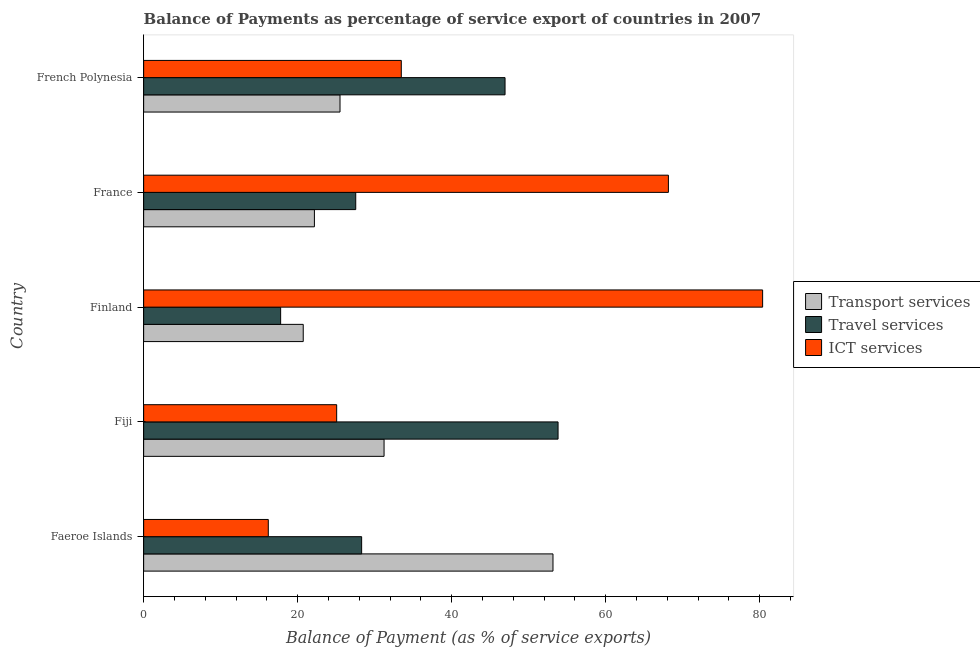How many groups of bars are there?
Offer a terse response. 5. Are the number of bars on each tick of the Y-axis equal?
Offer a terse response. Yes. How many bars are there on the 5th tick from the bottom?
Make the answer very short. 3. What is the label of the 2nd group of bars from the top?
Your answer should be very brief. France. What is the balance of payment of transport services in France?
Keep it short and to the point. 22.18. Across all countries, what is the maximum balance of payment of travel services?
Provide a short and direct response. 53.82. Across all countries, what is the minimum balance of payment of travel services?
Your response must be concise. 17.79. In which country was the balance of payment of ict services maximum?
Your answer should be very brief. Finland. In which country was the balance of payment of ict services minimum?
Make the answer very short. Faeroe Islands. What is the total balance of payment of transport services in the graph?
Keep it short and to the point. 152.79. What is the difference between the balance of payment of travel services in Fiji and that in France?
Your response must be concise. 26.28. What is the difference between the balance of payment of ict services in Finland and the balance of payment of transport services in French Polynesia?
Make the answer very short. 54.88. What is the average balance of payment of travel services per country?
Make the answer very short. 34.88. What is the difference between the balance of payment of transport services and balance of payment of ict services in French Polynesia?
Ensure brevity in your answer.  -7.96. What is the ratio of the balance of payment of transport services in Fiji to that in France?
Your answer should be very brief. 1.41. Is the balance of payment of transport services in Fiji less than that in French Polynesia?
Keep it short and to the point. No. What is the difference between the highest and the second highest balance of payment of transport services?
Offer a very short reply. 21.94. What is the difference between the highest and the lowest balance of payment of ict services?
Your response must be concise. 64.2. In how many countries, is the balance of payment of travel services greater than the average balance of payment of travel services taken over all countries?
Keep it short and to the point. 2. Is the sum of the balance of payment of travel services in Finland and French Polynesia greater than the maximum balance of payment of transport services across all countries?
Ensure brevity in your answer.  Yes. What does the 1st bar from the top in French Polynesia represents?
Your response must be concise. ICT services. What does the 2nd bar from the bottom in Finland represents?
Offer a very short reply. Travel services. Is it the case that in every country, the sum of the balance of payment of transport services and balance of payment of travel services is greater than the balance of payment of ict services?
Offer a terse response. No. Are all the bars in the graph horizontal?
Provide a short and direct response. Yes. Does the graph contain any zero values?
Offer a very short reply. No. What is the title of the graph?
Your response must be concise. Balance of Payments as percentage of service export of countries in 2007. Does "Social Insurance" appear as one of the legend labels in the graph?
Your answer should be compact. No. What is the label or title of the X-axis?
Offer a very short reply. Balance of Payment (as % of service exports). What is the Balance of Payment (as % of service exports) of Transport services in Faeroe Islands?
Offer a terse response. 53.16. What is the Balance of Payment (as % of service exports) in Travel services in Faeroe Islands?
Give a very brief answer. 28.31. What is the Balance of Payment (as % of service exports) of ICT services in Faeroe Islands?
Provide a short and direct response. 16.19. What is the Balance of Payment (as % of service exports) in Transport services in Fiji?
Your answer should be compact. 31.22. What is the Balance of Payment (as % of service exports) of Travel services in Fiji?
Make the answer very short. 53.82. What is the Balance of Payment (as % of service exports) in ICT services in Fiji?
Your answer should be compact. 25.07. What is the Balance of Payment (as % of service exports) in Transport services in Finland?
Provide a succinct answer. 20.72. What is the Balance of Payment (as % of service exports) in Travel services in Finland?
Provide a short and direct response. 17.79. What is the Balance of Payment (as % of service exports) of ICT services in Finland?
Provide a succinct answer. 80.38. What is the Balance of Payment (as % of service exports) in Transport services in France?
Offer a terse response. 22.18. What is the Balance of Payment (as % of service exports) in Travel services in France?
Make the answer very short. 27.54. What is the Balance of Payment (as % of service exports) of ICT services in France?
Provide a succinct answer. 68.15. What is the Balance of Payment (as % of service exports) of Transport services in French Polynesia?
Your response must be concise. 25.5. What is the Balance of Payment (as % of service exports) in Travel services in French Polynesia?
Keep it short and to the point. 46.93. What is the Balance of Payment (as % of service exports) in ICT services in French Polynesia?
Your answer should be very brief. 33.46. Across all countries, what is the maximum Balance of Payment (as % of service exports) in Transport services?
Give a very brief answer. 53.16. Across all countries, what is the maximum Balance of Payment (as % of service exports) of Travel services?
Provide a succinct answer. 53.82. Across all countries, what is the maximum Balance of Payment (as % of service exports) in ICT services?
Keep it short and to the point. 80.38. Across all countries, what is the minimum Balance of Payment (as % of service exports) in Transport services?
Your answer should be very brief. 20.72. Across all countries, what is the minimum Balance of Payment (as % of service exports) in Travel services?
Your answer should be very brief. 17.79. Across all countries, what is the minimum Balance of Payment (as % of service exports) in ICT services?
Your response must be concise. 16.19. What is the total Balance of Payment (as % of service exports) in Transport services in the graph?
Provide a succinct answer. 152.79. What is the total Balance of Payment (as % of service exports) of Travel services in the graph?
Your response must be concise. 174.4. What is the total Balance of Payment (as % of service exports) of ICT services in the graph?
Ensure brevity in your answer.  223.25. What is the difference between the Balance of Payment (as % of service exports) of Transport services in Faeroe Islands and that in Fiji?
Offer a very short reply. 21.94. What is the difference between the Balance of Payment (as % of service exports) in Travel services in Faeroe Islands and that in Fiji?
Your response must be concise. -25.51. What is the difference between the Balance of Payment (as % of service exports) of ICT services in Faeroe Islands and that in Fiji?
Give a very brief answer. -8.88. What is the difference between the Balance of Payment (as % of service exports) in Transport services in Faeroe Islands and that in Finland?
Keep it short and to the point. 32.44. What is the difference between the Balance of Payment (as % of service exports) of Travel services in Faeroe Islands and that in Finland?
Your response must be concise. 10.52. What is the difference between the Balance of Payment (as % of service exports) of ICT services in Faeroe Islands and that in Finland?
Keep it short and to the point. -64.2. What is the difference between the Balance of Payment (as % of service exports) in Transport services in Faeroe Islands and that in France?
Provide a succinct answer. 30.98. What is the difference between the Balance of Payment (as % of service exports) of Travel services in Faeroe Islands and that in France?
Ensure brevity in your answer.  0.77. What is the difference between the Balance of Payment (as % of service exports) in ICT services in Faeroe Islands and that in France?
Your answer should be very brief. -51.96. What is the difference between the Balance of Payment (as % of service exports) in Transport services in Faeroe Islands and that in French Polynesia?
Keep it short and to the point. 27.66. What is the difference between the Balance of Payment (as % of service exports) in Travel services in Faeroe Islands and that in French Polynesia?
Your response must be concise. -18.62. What is the difference between the Balance of Payment (as % of service exports) of ICT services in Faeroe Islands and that in French Polynesia?
Ensure brevity in your answer.  -17.27. What is the difference between the Balance of Payment (as % of service exports) of Transport services in Fiji and that in Finland?
Your response must be concise. 10.5. What is the difference between the Balance of Payment (as % of service exports) of Travel services in Fiji and that in Finland?
Provide a short and direct response. 36.03. What is the difference between the Balance of Payment (as % of service exports) of ICT services in Fiji and that in Finland?
Your response must be concise. -55.32. What is the difference between the Balance of Payment (as % of service exports) in Transport services in Fiji and that in France?
Your response must be concise. 9.05. What is the difference between the Balance of Payment (as % of service exports) of Travel services in Fiji and that in France?
Keep it short and to the point. 26.28. What is the difference between the Balance of Payment (as % of service exports) of ICT services in Fiji and that in France?
Ensure brevity in your answer.  -43.08. What is the difference between the Balance of Payment (as % of service exports) of Transport services in Fiji and that in French Polynesia?
Your answer should be compact. 5.72. What is the difference between the Balance of Payment (as % of service exports) in Travel services in Fiji and that in French Polynesia?
Offer a very short reply. 6.89. What is the difference between the Balance of Payment (as % of service exports) of ICT services in Fiji and that in French Polynesia?
Your response must be concise. -8.39. What is the difference between the Balance of Payment (as % of service exports) in Transport services in Finland and that in France?
Offer a very short reply. -1.45. What is the difference between the Balance of Payment (as % of service exports) of Travel services in Finland and that in France?
Your answer should be very brief. -9.75. What is the difference between the Balance of Payment (as % of service exports) of ICT services in Finland and that in France?
Your answer should be compact. 12.24. What is the difference between the Balance of Payment (as % of service exports) in Transport services in Finland and that in French Polynesia?
Make the answer very short. -4.78. What is the difference between the Balance of Payment (as % of service exports) in Travel services in Finland and that in French Polynesia?
Provide a succinct answer. -29.14. What is the difference between the Balance of Payment (as % of service exports) in ICT services in Finland and that in French Polynesia?
Offer a very short reply. 46.93. What is the difference between the Balance of Payment (as % of service exports) in Transport services in France and that in French Polynesia?
Provide a succinct answer. -3.33. What is the difference between the Balance of Payment (as % of service exports) of Travel services in France and that in French Polynesia?
Offer a terse response. -19.39. What is the difference between the Balance of Payment (as % of service exports) of ICT services in France and that in French Polynesia?
Ensure brevity in your answer.  34.69. What is the difference between the Balance of Payment (as % of service exports) of Transport services in Faeroe Islands and the Balance of Payment (as % of service exports) of Travel services in Fiji?
Offer a terse response. -0.66. What is the difference between the Balance of Payment (as % of service exports) in Transport services in Faeroe Islands and the Balance of Payment (as % of service exports) in ICT services in Fiji?
Offer a terse response. 28.09. What is the difference between the Balance of Payment (as % of service exports) of Travel services in Faeroe Islands and the Balance of Payment (as % of service exports) of ICT services in Fiji?
Offer a terse response. 3.24. What is the difference between the Balance of Payment (as % of service exports) of Transport services in Faeroe Islands and the Balance of Payment (as % of service exports) of Travel services in Finland?
Give a very brief answer. 35.37. What is the difference between the Balance of Payment (as % of service exports) of Transport services in Faeroe Islands and the Balance of Payment (as % of service exports) of ICT services in Finland?
Offer a very short reply. -27.22. What is the difference between the Balance of Payment (as % of service exports) of Travel services in Faeroe Islands and the Balance of Payment (as % of service exports) of ICT services in Finland?
Provide a succinct answer. -52.07. What is the difference between the Balance of Payment (as % of service exports) in Transport services in Faeroe Islands and the Balance of Payment (as % of service exports) in Travel services in France?
Your answer should be very brief. 25.62. What is the difference between the Balance of Payment (as % of service exports) of Transport services in Faeroe Islands and the Balance of Payment (as % of service exports) of ICT services in France?
Your answer should be very brief. -14.99. What is the difference between the Balance of Payment (as % of service exports) of Travel services in Faeroe Islands and the Balance of Payment (as % of service exports) of ICT services in France?
Make the answer very short. -39.84. What is the difference between the Balance of Payment (as % of service exports) in Transport services in Faeroe Islands and the Balance of Payment (as % of service exports) in Travel services in French Polynesia?
Make the answer very short. 6.23. What is the difference between the Balance of Payment (as % of service exports) of Transport services in Faeroe Islands and the Balance of Payment (as % of service exports) of ICT services in French Polynesia?
Make the answer very short. 19.7. What is the difference between the Balance of Payment (as % of service exports) in Travel services in Faeroe Islands and the Balance of Payment (as % of service exports) in ICT services in French Polynesia?
Provide a short and direct response. -5.15. What is the difference between the Balance of Payment (as % of service exports) of Transport services in Fiji and the Balance of Payment (as % of service exports) of Travel services in Finland?
Give a very brief answer. 13.43. What is the difference between the Balance of Payment (as % of service exports) in Transport services in Fiji and the Balance of Payment (as % of service exports) in ICT services in Finland?
Ensure brevity in your answer.  -49.16. What is the difference between the Balance of Payment (as % of service exports) in Travel services in Fiji and the Balance of Payment (as % of service exports) in ICT services in Finland?
Offer a very short reply. -26.57. What is the difference between the Balance of Payment (as % of service exports) in Transport services in Fiji and the Balance of Payment (as % of service exports) in Travel services in France?
Keep it short and to the point. 3.68. What is the difference between the Balance of Payment (as % of service exports) in Transport services in Fiji and the Balance of Payment (as % of service exports) in ICT services in France?
Your answer should be compact. -36.93. What is the difference between the Balance of Payment (as % of service exports) in Travel services in Fiji and the Balance of Payment (as % of service exports) in ICT services in France?
Provide a succinct answer. -14.33. What is the difference between the Balance of Payment (as % of service exports) in Transport services in Fiji and the Balance of Payment (as % of service exports) in Travel services in French Polynesia?
Provide a short and direct response. -15.71. What is the difference between the Balance of Payment (as % of service exports) of Transport services in Fiji and the Balance of Payment (as % of service exports) of ICT services in French Polynesia?
Your answer should be compact. -2.24. What is the difference between the Balance of Payment (as % of service exports) in Travel services in Fiji and the Balance of Payment (as % of service exports) in ICT services in French Polynesia?
Ensure brevity in your answer.  20.36. What is the difference between the Balance of Payment (as % of service exports) of Transport services in Finland and the Balance of Payment (as % of service exports) of Travel services in France?
Provide a succinct answer. -6.82. What is the difference between the Balance of Payment (as % of service exports) of Transport services in Finland and the Balance of Payment (as % of service exports) of ICT services in France?
Offer a terse response. -47.42. What is the difference between the Balance of Payment (as % of service exports) of Travel services in Finland and the Balance of Payment (as % of service exports) of ICT services in France?
Provide a short and direct response. -50.36. What is the difference between the Balance of Payment (as % of service exports) in Transport services in Finland and the Balance of Payment (as % of service exports) in Travel services in French Polynesia?
Provide a succinct answer. -26.21. What is the difference between the Balance of Payment (as % of service exports) in Transport services in Finland and the Balance of Payment (as % of service exports) in ICT services in French Polynesia?
Give a very brief answer. -12.74. What is the difference between the Balance of Payment (as % of service exports) of Travel services in Finland and the Balance of Payment (as % of service exports) of ICT services in French Polynesia?
Provide a short and direct response. -15.67. What is the difference between the Balance of Payment (as % of service exports) in Transport services in France and the Balance of Payment (as % of service exports) in Travel services in French Polynesia?
Your response must be concise. -24.76. What is the difference between the Balance of Payment (as % of service exports) of Transport services in France and the Balance of Payment (as % of service exports) of ICT services in French Polynesia?
Your answer should be compact. -11.28. What is the difference between the Balance of Payment (as % of service exports) of Travel services in France and the Balance of Payment (as % of service exports) of ICT services in French Polynesia?
Keep it short and to the point. -5.92. What is the average Balance of Payment (as % of service exports) of Transport services per country?
Your answer should be compact. 30.56. What is the average Balance of Payment (as % of service exports) in Travel services per country?
Provide a short and direct response. 34.88. What is the average Balance of Payment (as % of service exports) in ICT services per country?
Make the answer very short. 44.65. What is the difference between the Balance of Payment (as % of service exports) of Transport services and Balance of Payment (as % of service exports) of Travel services in Faeroe Islands?
Provide a short and direct response. 24.85. What is the difference between the Balance of Payment (as % of service exports) of Transport services and Balance of Payment (as % of service exports) of ICT services in Faeroe Islands?
Ensure brevity in your answer.  36.97. What is the difference between the Balance of Payment (as % of service exports) of Travel services and Balance of Payment (as % of service exports) of ICT services in Faeroe Islands?
Make the answer very short. 12.12. What is the difference between the Balance of Payment (as % of service exports) in Transport services and Balance of Payment (as % of service exports) in Travel services in Fiji?
Keep it short and to the point. -22.6. What is the difference between the Balance of Payment (as % of service exports) of Transport services and Balance of Payment (as % of service exports) of ICT services in Fiji?
Give a very brief answer. 6.15. What is the difference between the Balance of Payment (as % of service exports) in Travel services and Balance of Payment (as % of service exports) in ICT services in Fiji?
Your response must be concise. 28.75. What is the difference between the Balance of Payment (as % of service exports) of Transport services and Balance of Payment (as % of service exports) of Travel services in Finland?
Make the answer very short. 2.93. What is the difference between the Balance of Payment (as % of service exports) in Transport services and Balance of Payment (as % of service exports) in ICT services in Finland?
Provide a succinct answer. -59.66. What is the difference between the Balance of Payment (as % of service exports) in Travel services and Balance of Payment (as % of service exports) in ICT services in Finland?
Offer a very short reply. -62.59. What is the difference between the Balance of Payment (as % of service exports) of Transport services and Balance of Payment (as % of service exports) of Travel services in France?
Your answer should be compact. -5.37. What is the difference between the Balance of Payment (as % of service exports) in Transport services and Balance of Payment (as % of service exports) in ICT services in France?
Your response must be concise. -45.97. What is the difference between the Balance of Payment (as % of service exports) in Travel services and Balance of Payment (as % of service exports) in ICT services in France?
Provide a succinct answer. -40.61. What is the difference between the Balance of Payment (as % of service exports) of Transport services and Balance of Payment (as % of service exports) of Travel services in French Polynesia?
Make the answer very short. -21.43. What is the difference between the Balance of Payment (as % of service exports) of Transport services and Balance of Payment (as % of service exports) of ICT services in French Polynesia?
Provide a short and direct response. -7.96. What is the difference between the Balance of Payment (as % of service exports) in Travel services and Balance of Payment (as % of service exports) in ICT services in French Polynesia?
Keep it short and to the point. 13.47. What is the ratio of the Balance of Payment (as % of service exports) of Transport services in Faeroe Islands to that in Fiji?
Give a very brief answer. 1.7. What is the ratio of the Balance of Payment (as % of service exports) of Travel services in Faeroe Islands to that in Fiji?
Keep it short and to the point. 0.53. What is the ratio of the Balance of Payment (as % of service exports) in ICT services in Faeroe Islands to that in Fiji?
Your response must be concise. 0.65. What is the ratio of the Balance of Payment (as % of service exports) in Transport services in Faeroe Islands to that in Finland?
Provide a succinct answer. 2.57. What is the ratio of the Balance of Payment (as % of service exports) of Travel services in Faeroe Islands to that in Finland?
Your answer should be very brief. 1.59. What is the ratio of the Balance of Payment (as % of service exports) in ICT services in Faeroe Islands to that in Finland?
Your answer should be compact. 0.2. What is the ratio of the Balance of Payment (as % of service exports) in Transport services in Faeroe Islands to that in France?
Offer a terse response. 2.4. What is the ratio of the Balance of Payment (as % of service exports) of Travel services in Faeroe Islands to that in France?
Your answer should be compact. 1.03. What is the ratio of the Balance of Payment (as % of service exports) of ICT services in Faeroe Islands to that in France?
Ensure brevity in your answer.  0.24. What is the ratio of the Balance of Payment (as % of service exports) of Transport services in Faeroe Islands to that in French Polynesia?
Make the answer very short. 2.08. What is the ratio of the Balance of Payment (as % of service exports) in Travel services in Faeroe Islands to that in French Polynesia?
Keep it short and to the point. 0.6. What is the ratio of the Balance of Payment (as % of service exports) of ICT services in Faeroe Islands to that in French Polynesia?
Provide a short and direct response. 0.48. What is the ratio of the Balance of Payment (as % of service exports) in Transport services in Fiji to that in Finland?
Ensure brevity in your answer.  1.51. What is the ratio of the Balance of Payment (as % of service exports) of Travel services in Fiji to that in Finland?
Provide a succinct answer. 3.03. What is the ratio of the Balance of Payment (as % of service exports) of ICT services in Fiji to that in Finland?
Offer a terse response. 0.31. What is the ratio of the Balance of Payment (as % of service exports) in Transport services in Fiji to that in France?
Offer a terse response. 1.41. What is the ratio of the Balance of Payment (as % of service exports) in Travel services in Fiji to that in France?
Provide a short and direct response. 1.95. What is the ratio of the Balance of Payment (as % of service exports) of ICT services in Fiji to that in France?
Give a very brief answer. 0.37. What is the ratio of the Balance of Payment (as % of service exports) of Transport services in Fiji to that in French Polynesia?
Provide a short and direct response. 1.22. What is the ratio of the Balance of Payment (as % of service exports) of Travel services in Fiji to that in French Polynesia?
Offer a terse response. 1.15. What is the ratio of the Balance of Payment (as % of service exports) of ICT services in Fiji to that in French Polynesia?
Ensure brevity in your answer.  0.75. What is the ratio of the Balance of Payment (as % of service exports) of Transport services in Finland to that in France?
Your response must be concise. 0.93. What is the ratio of the Balance of Payment (as % of service exports) in Travel services in Finland to that in France?
Keep it short and to the point. 0.65. What is the ratio of the Balance of Payment (as % of service exports) in ICT services in Finland to that in France?
Make the answer very short. 1.18. What is the ratio of the Balance of Payment (as % of service exports) in Transport services in Finland to that in French Polynesia?
Give a very brief answer. 0.81. What is the ratio of the Balance of Payment (as % of service exports) in Travel services in Finland to that in French Polynesia?
Provide a short and direct response. 0.38. What is the ratio of the Balance of Payment (as % of service exports) of ICT services in Finland to that in French Polynesia?
Provide a short and direct response. 2.4. What is the ratio of the Balance of Payment (as % of service exports) of Transport services in France to that in French Polynesia?
Offer a terse response. 0.87. What is the ratio of the Balance of Payment (as % of service exports) in Travel services in France to that in French Polynesia?
Keep it short and to the point. 0.59. What is the ratio of the Balance of Payment (as % of service exports) in ICT services in France to that in French Polynesia?
Make the answer very short. 2.04. What is the difference between the highest and the second highest Balance of Payment (as % of service exports) of Transport services?
Provide a short and direct response. 21.94. What is the difference between the highest and the second highest Balance of Payment (as % of service exports) in Travel services?
Your answer should be compact. 6.89. What is the difference between the highest and the second highest Balance of Payment (as % of service exports) of ICT services?
Your answer should be very brief. 12.24. What is the difference between the highest and the lowest Balance of Payment (as % of service exports) of Transport services?
Give a very brief answer. 32.44. What is the difference between the highest and the lowest Balance of Payment (as % of service exports) of Travel services?
Offer a very short reply. 36.03. What is the difference between the highest and the lowest Balance of Payment (as % of service exports) in ICT services?
Offer a very short reply. 64.2. 